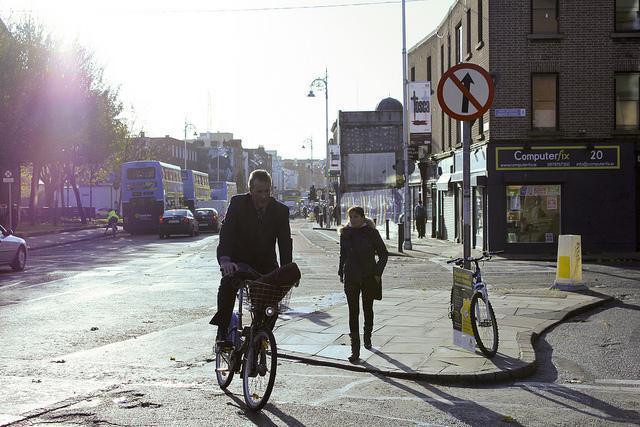How many bikes are pictured?
Give a very brief answer. 2. How many people are in the photo?
Give a very brief answer. 2. 